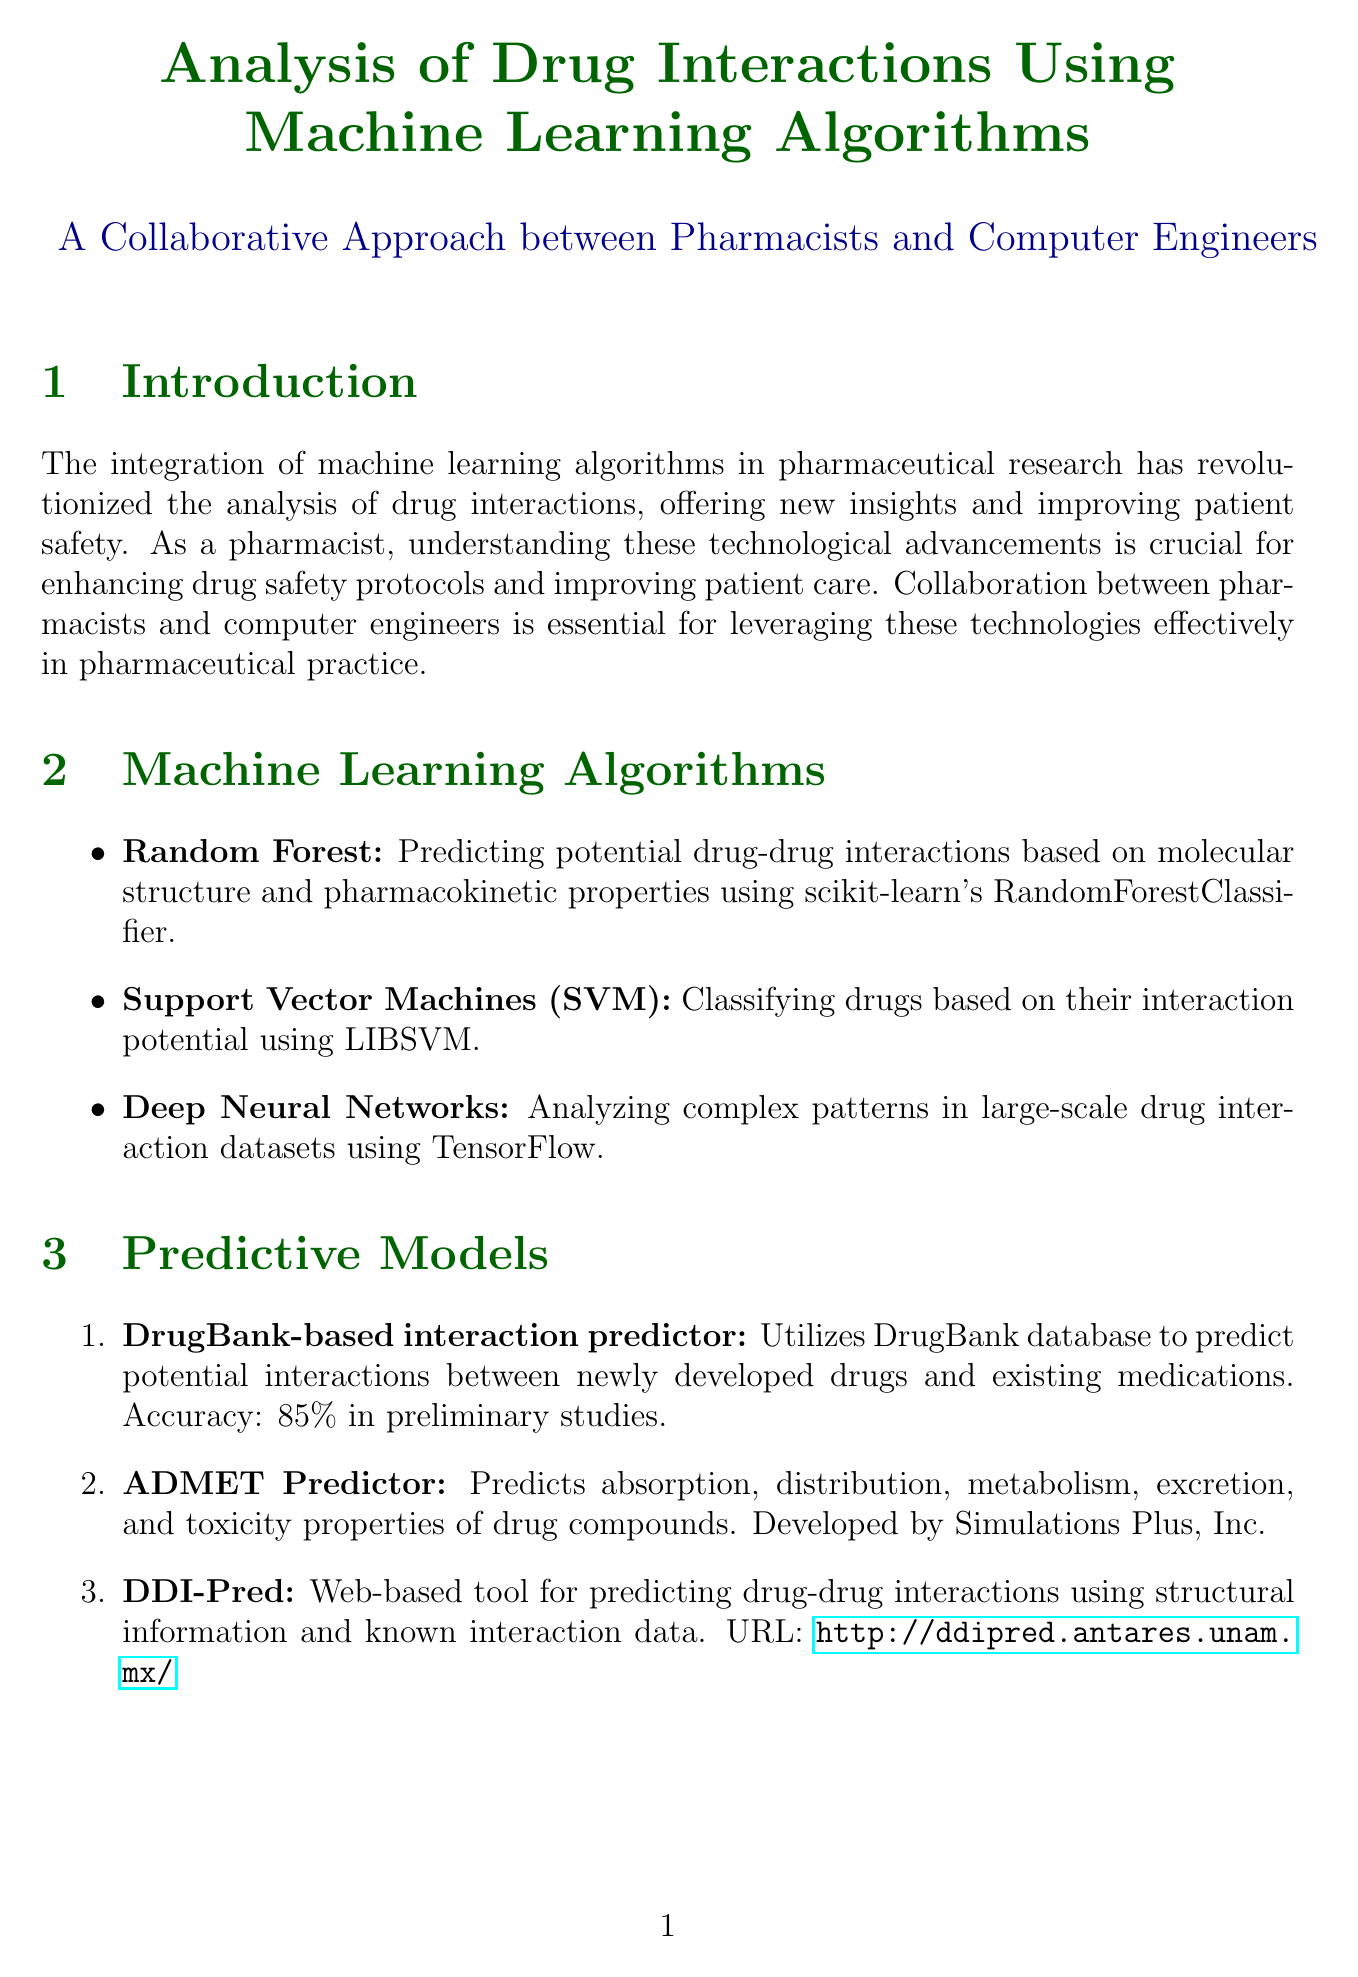What is the main focus of the report? The main focus of the report is on how machine learning algorithms are used in pharmaceutical research to analyze drug interactions.
Answer: drug interactions Which machine learning algorithm is used for predicting potential drug-drug interactions? The report mentions Random Forest being used for predicting potential drug-drug interactions.
Answer: Random Forest What is the accuracy percentage of the DrugBank-based interaction predictor in preliminary studies? The accuracy of the DrugBank-based interaction predictor in preliminary studies is stated in the document.
Answer: 85% Which tool is mentioned for visualizing complex networks of drug interactions? The document describes Cytoscape as the tool used for visualizing complex networks of drug interactions.
Answer: Cytoscape What challenge related to machine learning models is mentioned in the document? The report details several challenges, including data quality and standardization as one major challenge.
Answer: Data quality and standardization What was the outcome of the case study on improving antibiotic prescribing practices? The report specifies the outcome of the case study regarding antibiotic prescribing practices and its impact on adverse drug events.
Answer: Reduced adverse drug events related to antibiotic interactions by 30% What does the report suggest as a potential solution for model interpretability? It suggests incorporating techniques like SHAP for improving model interpretability as a potential solution.
Answer: SHAP Which company developed the ADMET Predictor tool? The document provides information about the developer of the ADMET Predictor tool.
Answer: Simulations Plus, Inc 